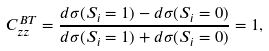<formula> <loc_0><loc_0><loc_500><loc_500>C ^ { B T } _ { z z } = \frac { d \sigma ( S _ { i } = 1 ) - d \sigma ( S _ { i } = 0 ) } { d \sigma ( S _ { i } = 1 ) + d \sigma ( S _ { i } = 0 ) } = 1 ,</formula> 